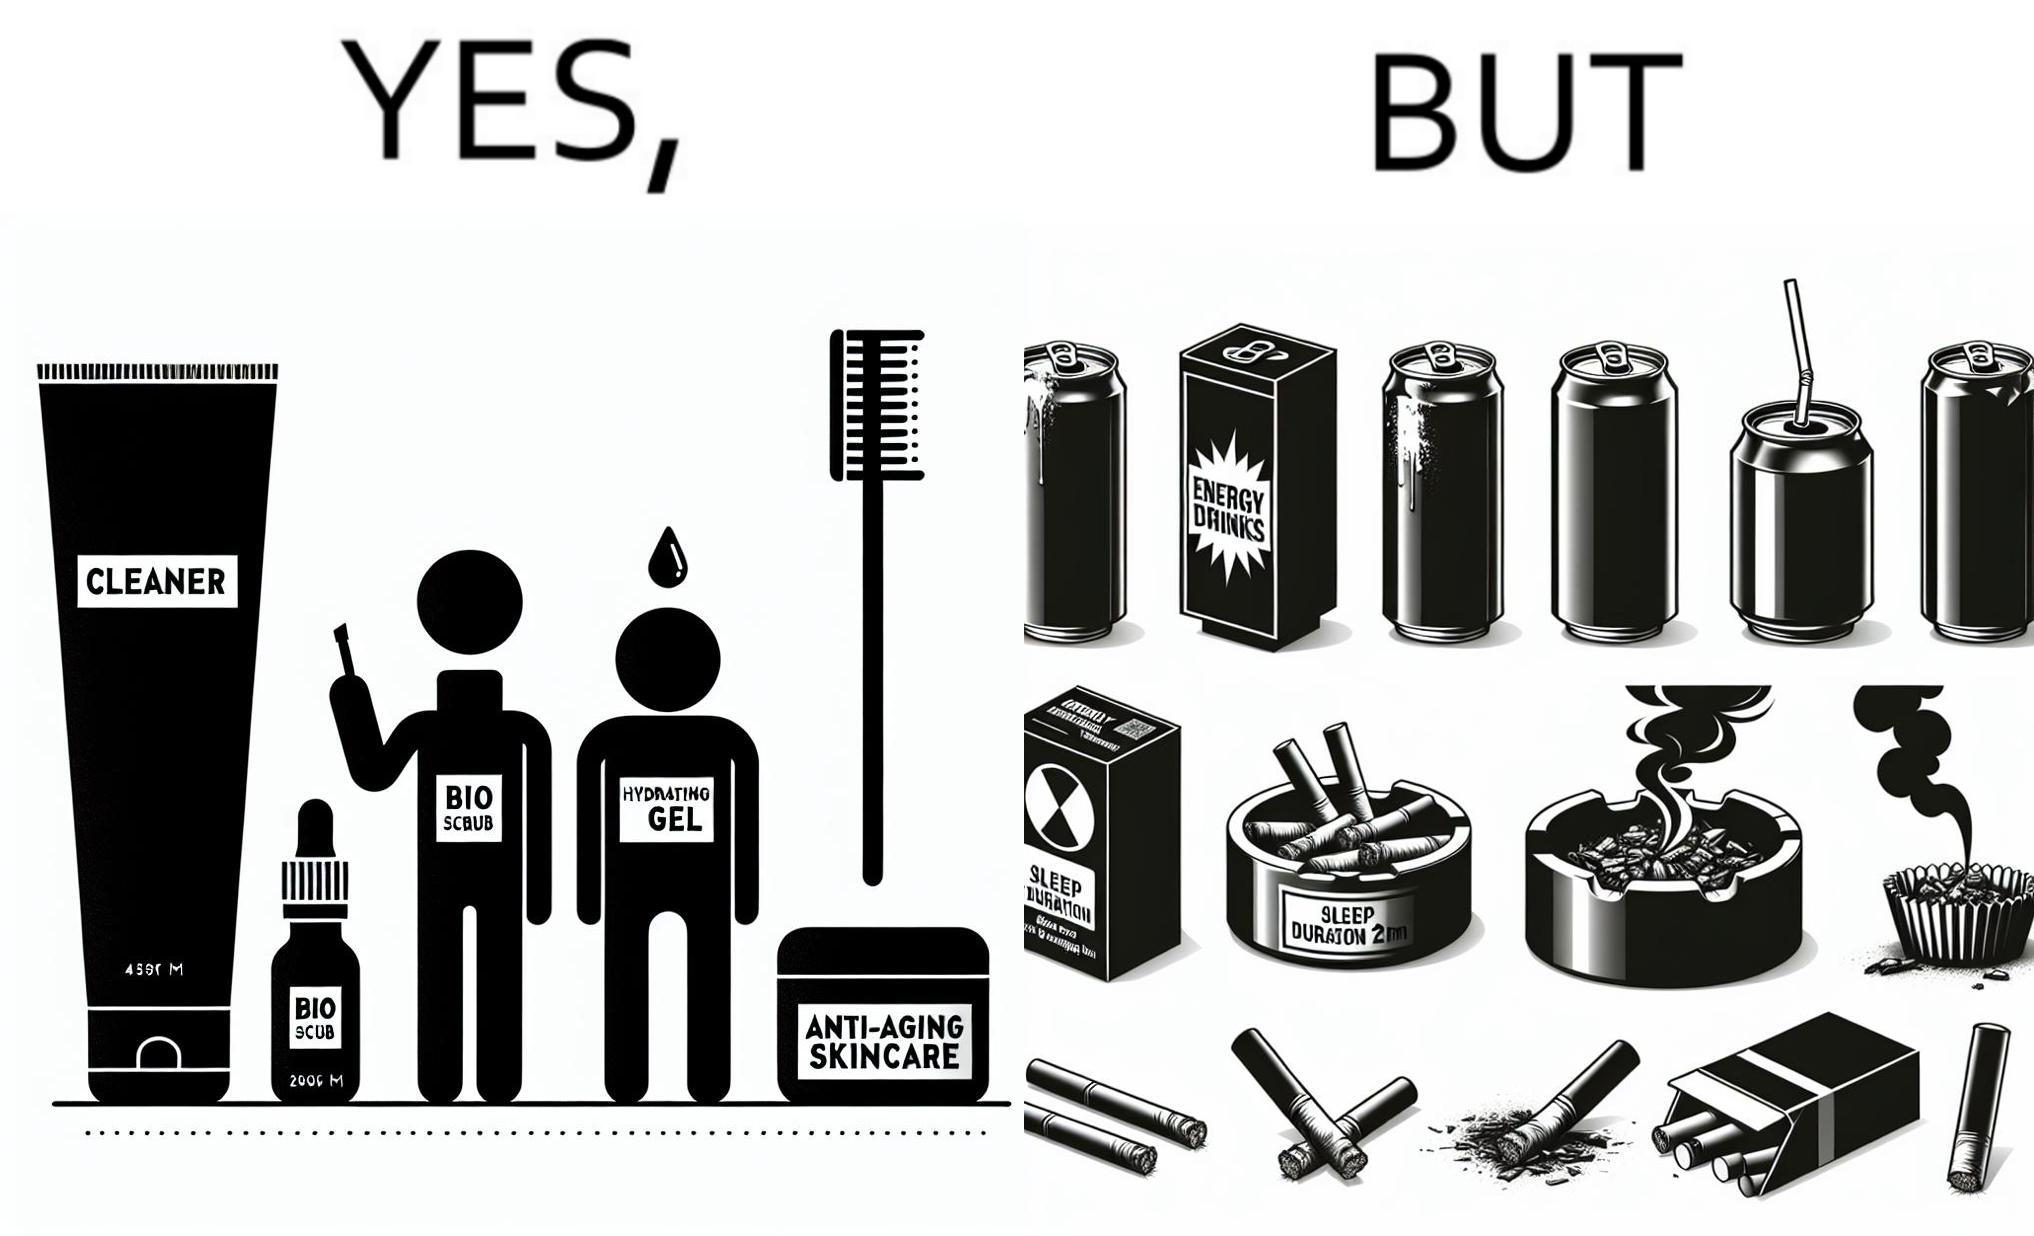What do you see in each half of this image? In the left part of the image: 4 Skincare products, arranged aesthetically. A tube labeled "Cleaner". A tube labeled "BIO SCRUB". A dropper bottle labeled "HYDRATING GEL". A jar called "ANTI-AGING SKINCARE". In the right part of the image: 9 cans of red bull, some standing upright, some crushed. Cans have blue and red colors. An ashtray with many cigarette butts in it and has smoke coming out. A banner that says "Sleep duration 2h 5min". 